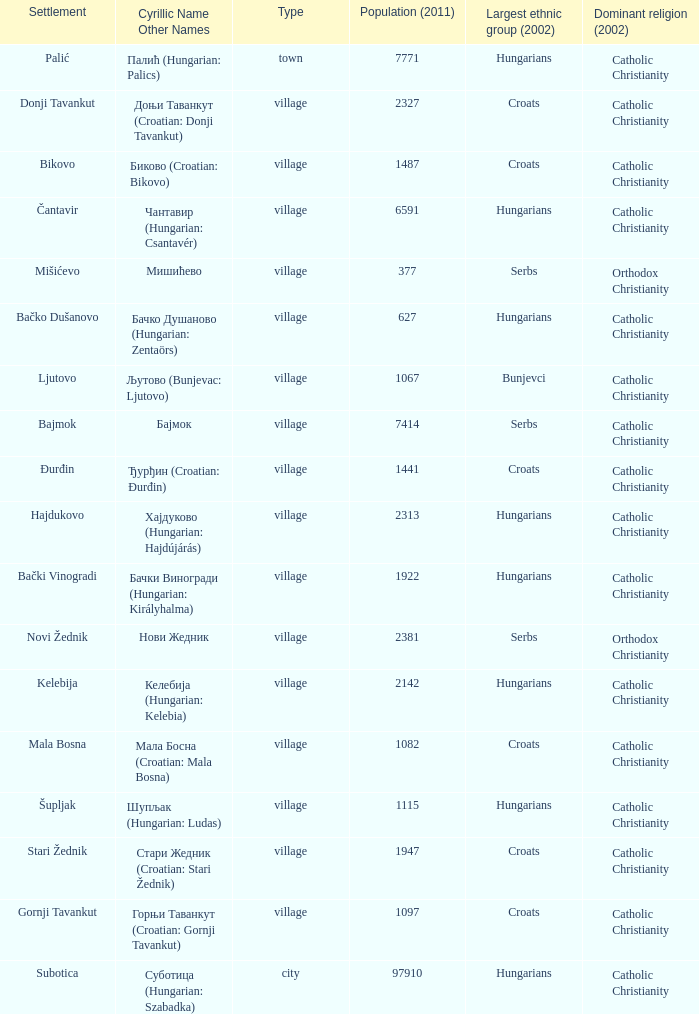What are the cyrillic and other names of the settlement whose population is 6591? Чантавир (Hungarian: Csantavér). 